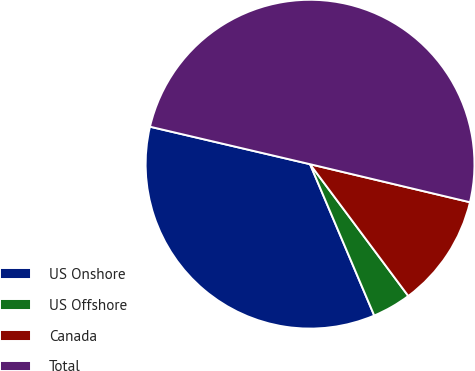<chart> <loc_0><loc_0><loc_500><loc_500><pie_chart><fcel>US Onshore<fcel>US Offshore<fcel>Canada<fcel>Total<nl><fcel>35.05%<fcel>3.81%<fcel>11.09%<fcel>50.06%<nl></chart> 